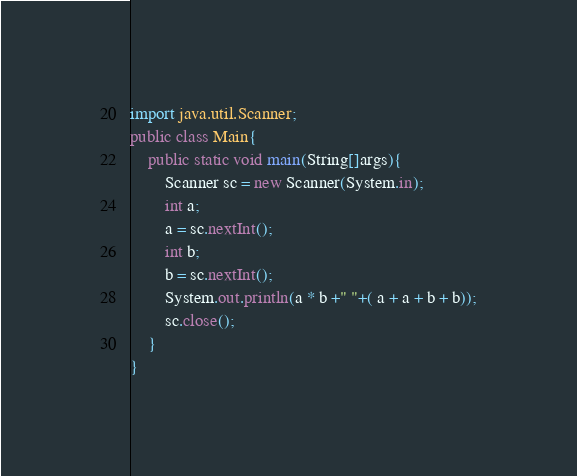Convert code to text. <code><loc_0><loc_0><loc_500><loc_500><_Java_>import java.util.Scanner;
public class Main{
    public static void main(String[]args){
        Scanner sc = new Scanner(System.in);
        int a;
        a = sc.nextInt();
        int b;
        b = sc.nextInt();
        System.out.println(a * b +" "+( a + a + b + b));
        sc.close();
    }
}
</code> 